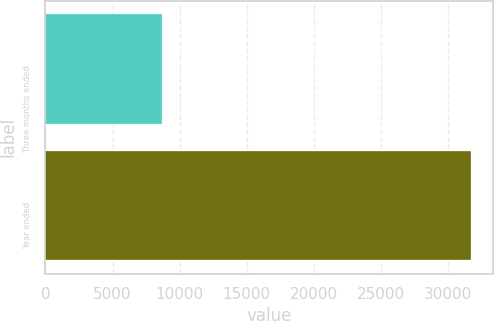Convert chart to OTSL. <chart><loc_0><loc_0><loc_500><loc_500><bar_chart><fcel>Three months ended<fcel>Year ended<nl><fcel>8722<fcel>31759<nl></chart> 